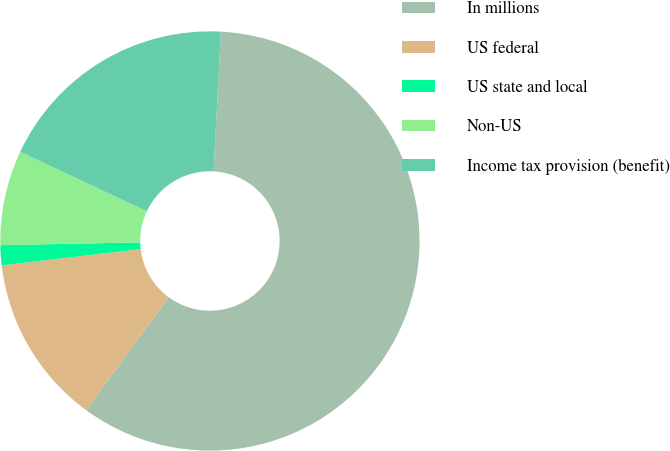Convert chart to OTSL. <chart><loc_0><loc_0><loc_500><loc_500><pie_chart><fcel>In millions<fcel>US federal<fcel>US state and local<fcel>Non-US<fcel>Income tax provision (benefit)<nl><fcel>59.24%<fcel>13.08%<fcel>1.54%<fcel>7.31%<fcel>18.85%<nl></chart> 